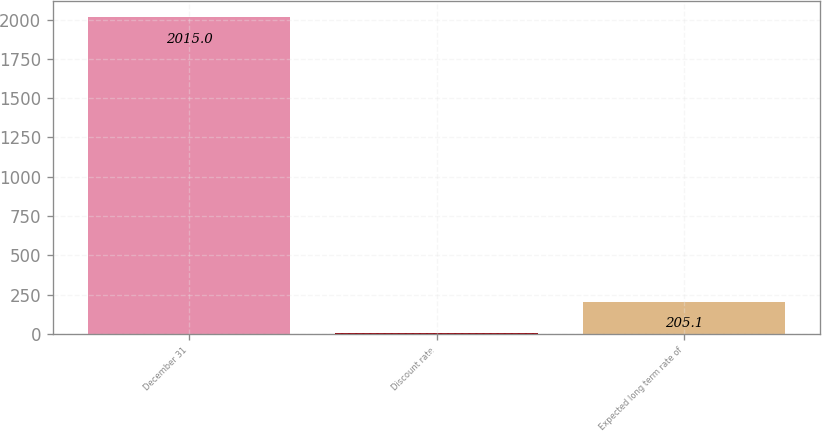<chart> <loc_0><loc_0><loc_500><loc_500><bar_chart><fcel>December 31<fcel>Discount rate<fcel>Expected long term rate of<nl><fcel>2015<fcel>4<fcel>205.1<nl></chart> 